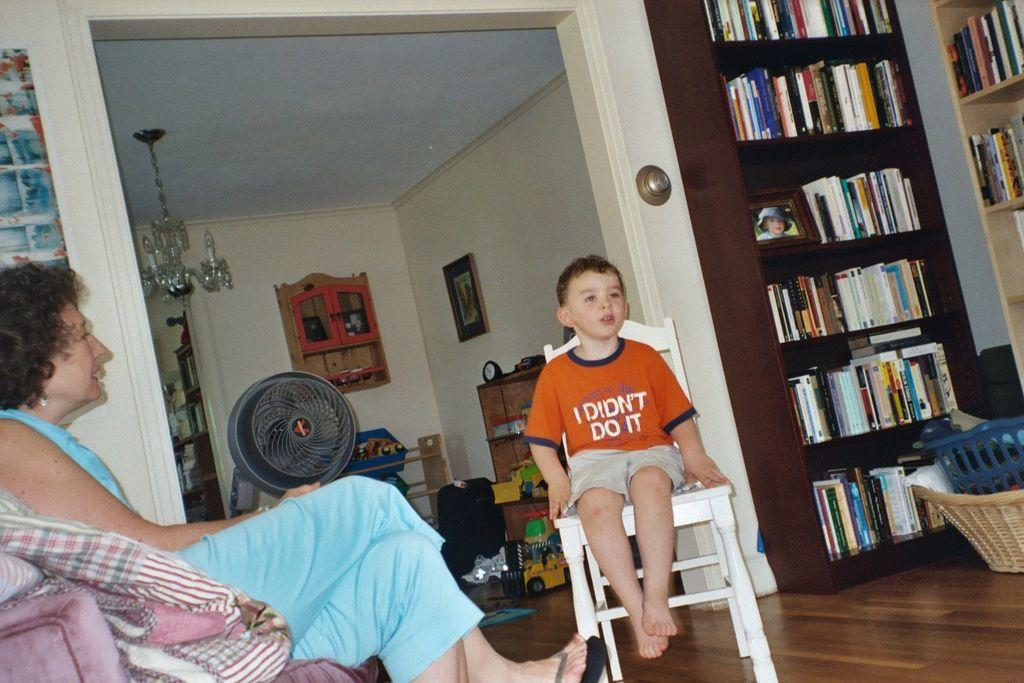<image>
Describe the image concisely. A small child sitting on a chair wearing a shirt that says I didn't do it. 